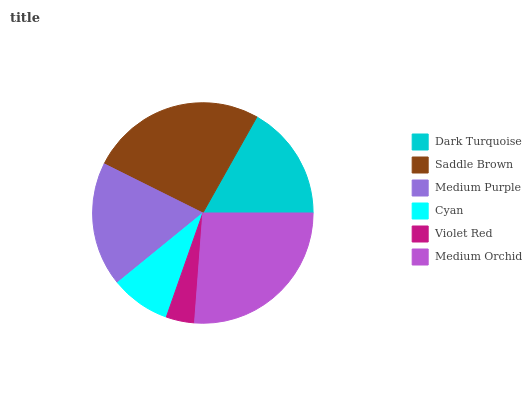Is Violet Red the minimum?
Answer yes or no. Yes. Is Medium Orchid the maximum?
Answer yes or no. Yes. Is Saddle Brown the minimum?
Answer yes or no. No. Is Saddle Brown the maximum?
Answer yes or no. No. Is Saddle Brown greater than Dark Turquoise?
Answer yes or no. Yes. Is Dark Turquoise less than Saddle Brown?
Answer yes or no. Yes. Is Dark Turquoise greater than Saddle Brown?
Answer yes or no. No. Is Saddle Brown less than Dark Turquoise?
Answer yes or no. No. Is Medium Purple the high median?
Answer yes or no. Yes. Is Dark Turquoise the low median?
Answer yes or no. Yes. Is Saddle Brown the high median?
Answer yes or no. No. Is Medium Orchid the low median?
Answer yes or no. No. 